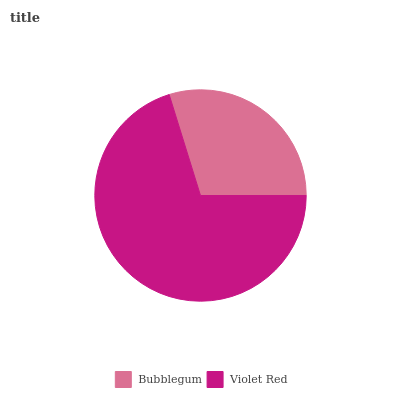Is Bubblegum the minimum?
Answer yes or no. Yes. Is Violet Red the maximum?
Answer yes or no. Yes. Is Violet Red the minimum?
Answer yes or no. No. Is Violet Red greater than Bubblegum?
Answer yes or no. Yes. Is Bubblegum less than Violet Red?
Answer yes or no. Yes. Is Bubblegum greater than Violet Red?
Answer yes or no. No. Is Violet Red less than Bubblegum?
Answer yes or no. No. Is Violet Red the high median?
Answer yes or no. Yes. Is Bubblegum the low median?
Answer yes or no. Yes. Is Bubblegum the high median?
Answer yes or no. No. Is Violet Red the low median?
Answer yes or no. No. 